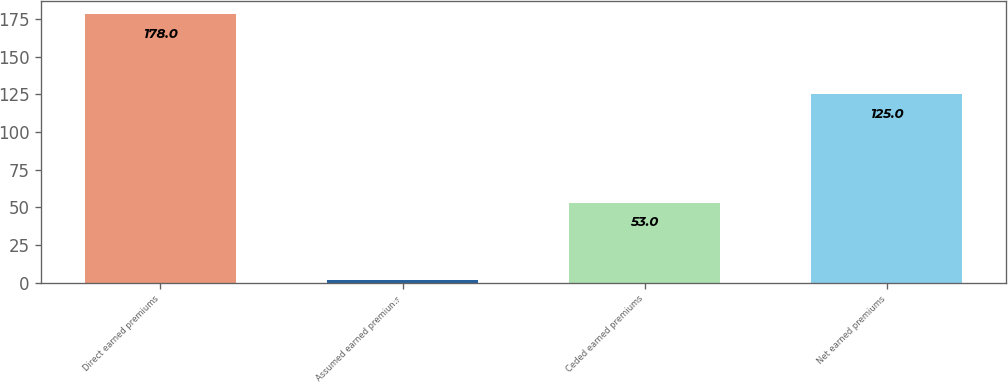Convert chart to OTSL. <chart><loc_0><loc_0><loc_500><loc_500><bar_chart><fcel>Direct earned premiums<fcel>Assumed earned premiums<fcel>Ceded earned premiums<fcel>Net earned premiums<nl><fcel>178<fcel>1.68<fcel>53<fcel>125<nl></chart> 